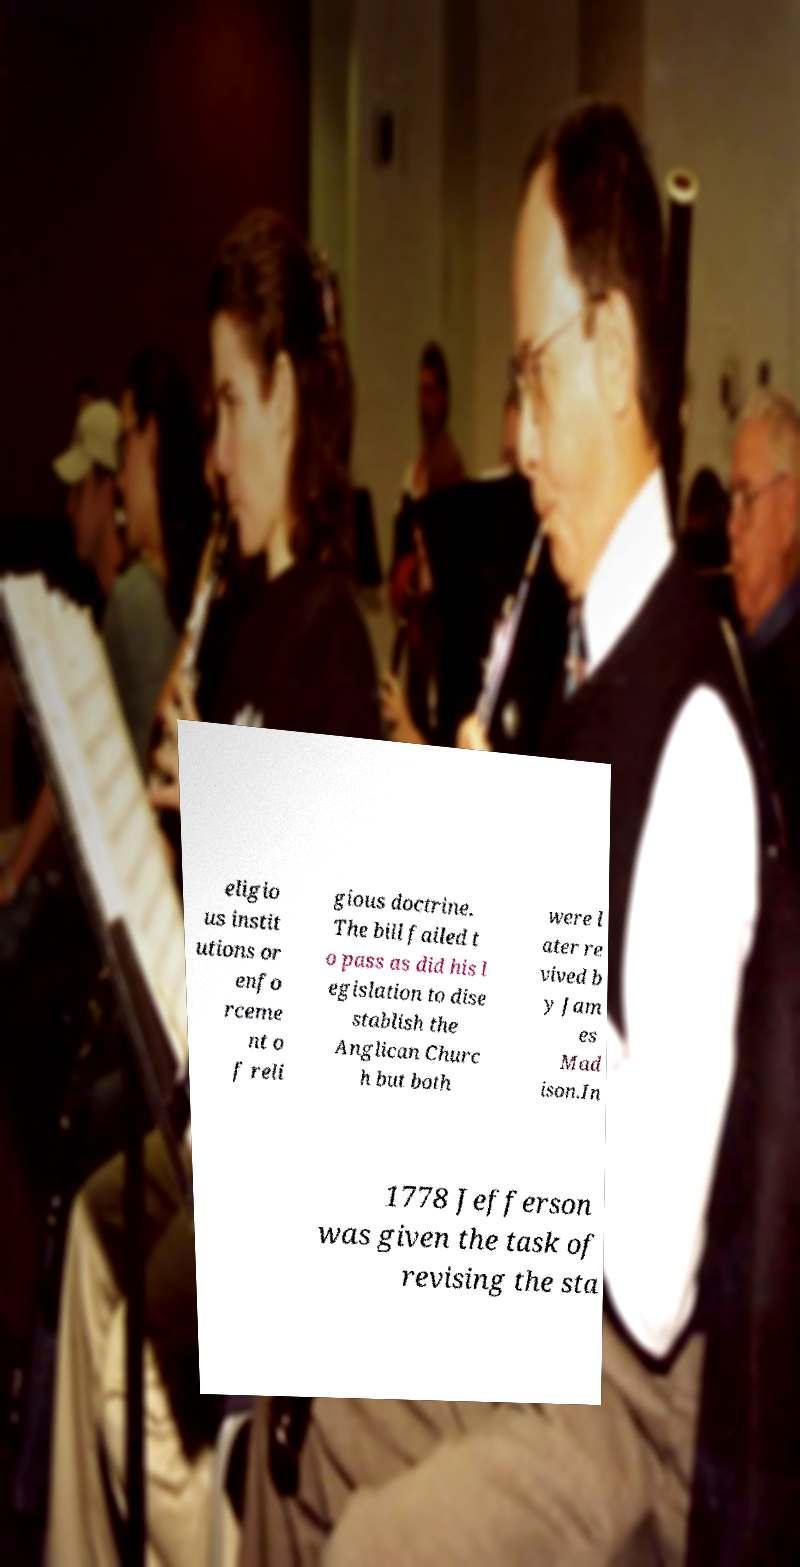Please identify and transcribe the text found in this image. eligio us instit utions or enfo rceme nt o f reli gious doctrine. The bill failed t o pass as did his l egislation to dise stablish the Anglican Churc h but both were l ater re vived b y Jam es Mad ison.In 1778 Jefferson was given the task of revising the sta 